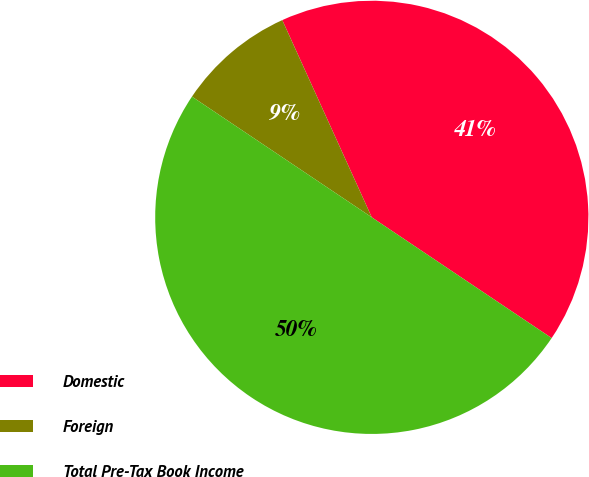Convert chart. <chart><loc_0><loc_0><loc_500><loc_500><pie_chart><fcel>Domestic<fcel>Foreign<fcel>Total Pre-Tax Book Income<nl><fcel>41.19%<fcel>8.81%<fcel>50.0%<nl></chart> 